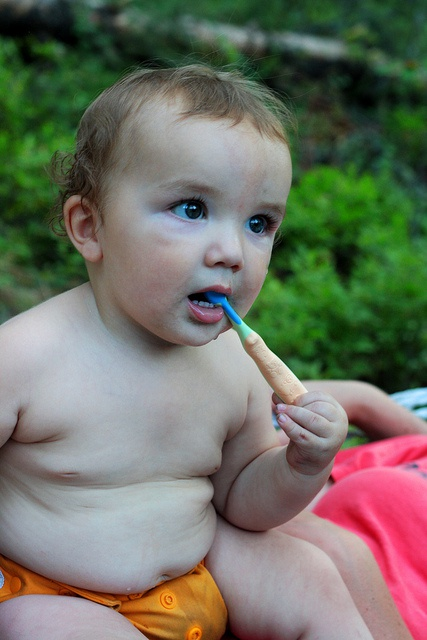Describe the objects in this image and their specific colors. I can see people in gray and darkgray tones and toothbrush in gray, beige, lightgray, and tan tones in this image. 